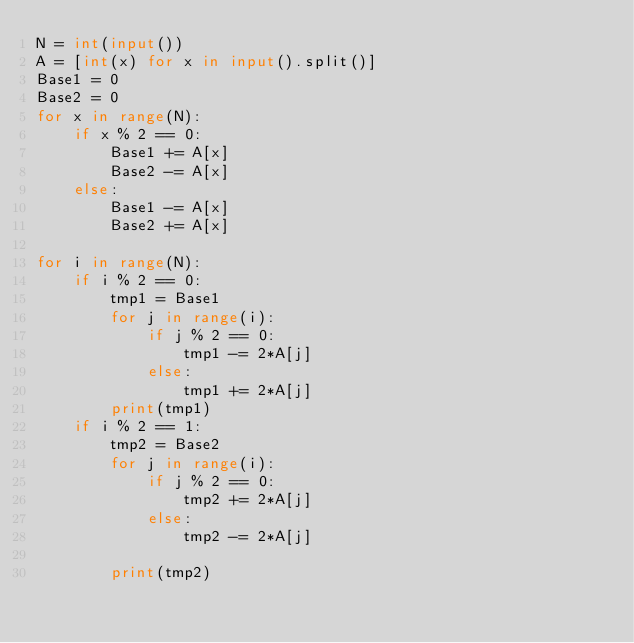Convert code to text. <code><loc_0><loc_0><loc_500><loc_500><_Python_>N = int(input())
A = [int(x) for x in input().split()]
Base1 = 0
Base2 = 0
for x in range(N):
    if x % 2 == 0:
        Base1 += A[x]
        Base2 -= A[x]
    else:
        Base1 -= A[x]
        Base2 += A[x]

for i in range(N):
    if i % 2 == 0:
        tmp1 = Base1
        for j in range(i):
            if j % 2 == 0:
                tmp1 -= 2*A[j]
            else:
                tmp1 += 2*A[j]
        print(tmp1)
    if i % 2 == 1:
        tmp2 = Base2
        for j in range(i):
            if j % 2 == 0:
                tmp2 += 2*A[j]
            else:
                tmp2 -= 2*A[j]

        print(tmp2)</code> 